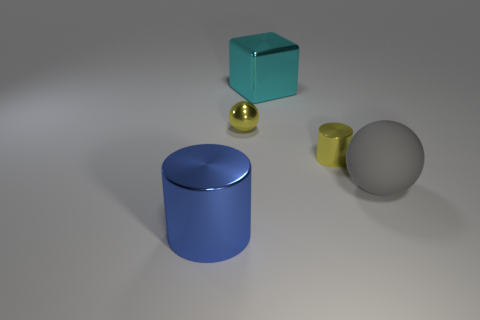Is the color of the tiny metal sphere the same as the tiny shiny cylinder?
Provide a succinct answer. Yes. Is the color of the cylinder right of the large blue shiny thing the same as the tiny ball?
Keep it short and to the point. Yes. What shape is the object that is the same color as the small cylinder?
Ensure brevity in your answer.  Sphere. There is a metal cylinder that is behind the blue metallic object; is it the same size as the large shiny cylinder?
Offer a very short reply. No. How many gray objects are either rubber objects or small spheres?
Offer a very short reply. 1. There is a cylinder that is the same color as the small metallic ball; what is its size?
Give a very brief answer. Small. There is a large cyan thing; what number of big metallic objects are to the left of it?
Offer a terse response. 1. There is a ball that is right of the big metallic object that is behind the cylinder to the left of the big cube; what is its size?
Ensure brevity in your answer.  Large. There is a shiny cylinder on the left side of the tiny metal object that is left of the yellow shiny cylinder; is there a small yellow thing that is to the right of it?
Offer a terse response. Yes. Is the number of small blue cylinders greater than the number of shiny cubes?
Give a very brief answer. No. 